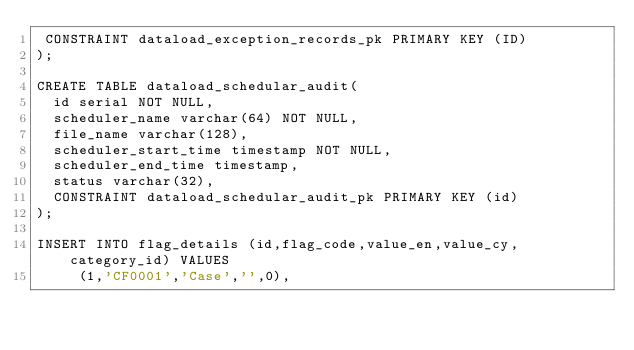<code> <loc_0><loc_0><loc_500><loc_500><_SQL_> CONSTRAINT dataload_exception_records_pk PRIMARY KEY (ID)
);

CREATE TABLE dataload_schedular_audit(
  id serial NOT NULL,
  scheduler_name varchar(64) NOT NULL,
  file_name varchar(128),
  scheduler_start_time timestamp NOT NULL,
  scheduler_end_time timestamp,
  status varchar(32),
  CONSTRAINT dataload_schedular_audit_pk PRIMARY KEY (id)
);

INSERT INTO flag_details (id,flag_code,value_en,value_cy,category_id) VALUES
	 (1,'CF0001','Case','',0),</code> 